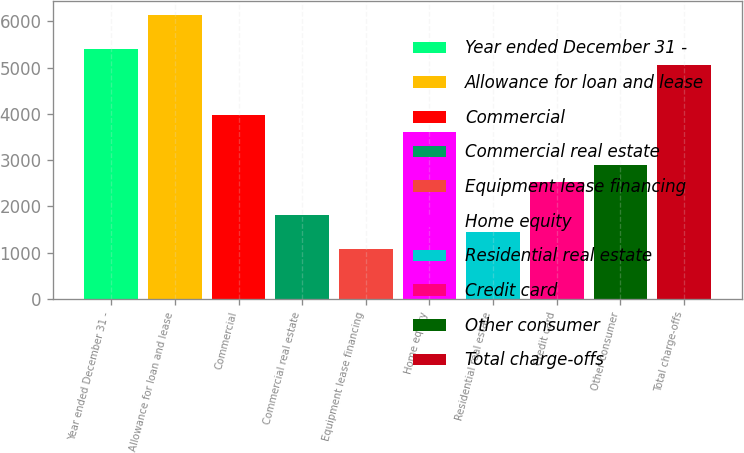<chart> <loc_0><loc_0><loc_500><loc_500><bar_chart><fcel>Year ended December 31 -<fcel>Allowance for loan and lease<fcel>Commercial<fcel>Commercial real estate<fcel>Equipment lease financing<fcel>Home equity<fcel>Residential real estate<fcel>Credit card<fcel>Other consumer<fcel>Total charge-offs<nl><fcel>5412.73<fcel>6134.21<fcel>3969.77<fcel>1805.33<fcel>1083.85<fcel>3609.03<fcel>1444.59<fcel>2526.81<fcel>2887.55<fcel>5051.99<nl></chart> 